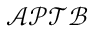Convert formula to latex. <formula><loc_0><loc_0><loc_500><loc_500>\mathcal { A P T B }</formula> 